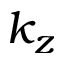<formula> <loc_0><loc_0><loc_500><loc_500>k _ { z }</formula> 